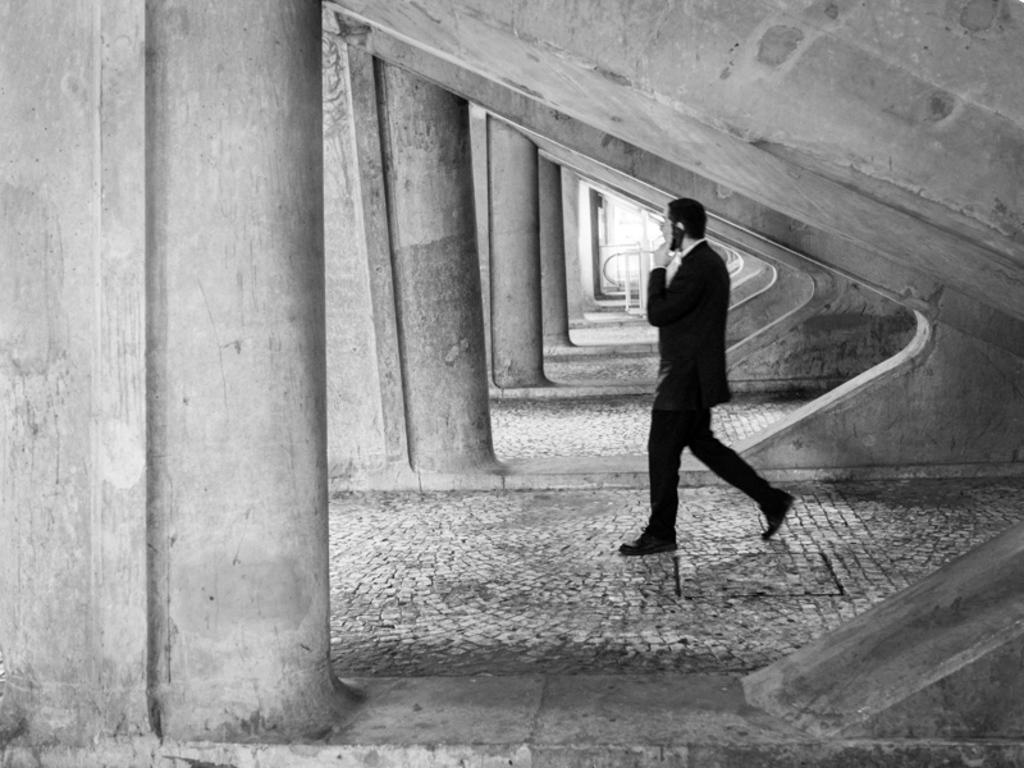What is the color scheme of the image? The image is black and white. Who is present in the image? There is a man in the image. What is the man holding in the image? The man is holding a phone. What architectural features can be seen in the foreground of the image? There are pillars in the foreground of the image. Can you see any steam coming from the man's dad in the image? There is no dad or steam present in the image. 